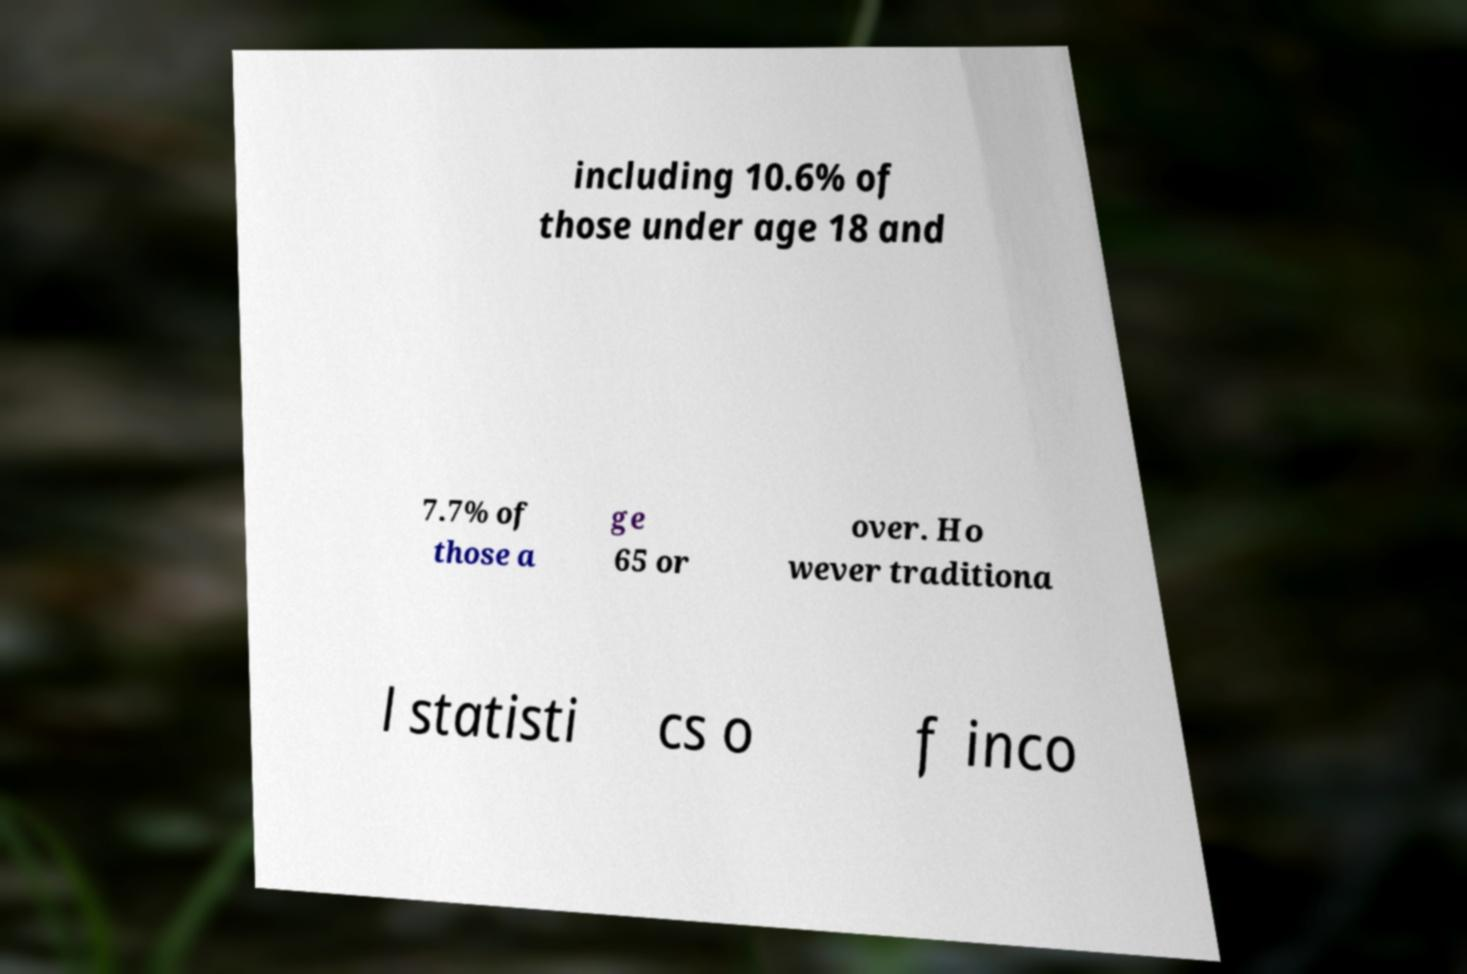There's text embedded in this image that I need extracted. Can you transcribe it verbatim? including 10.6% of those under age 18 and 7.7% of those a ge 65 or over. Ho wever traditiona l statisti cs o f inco 